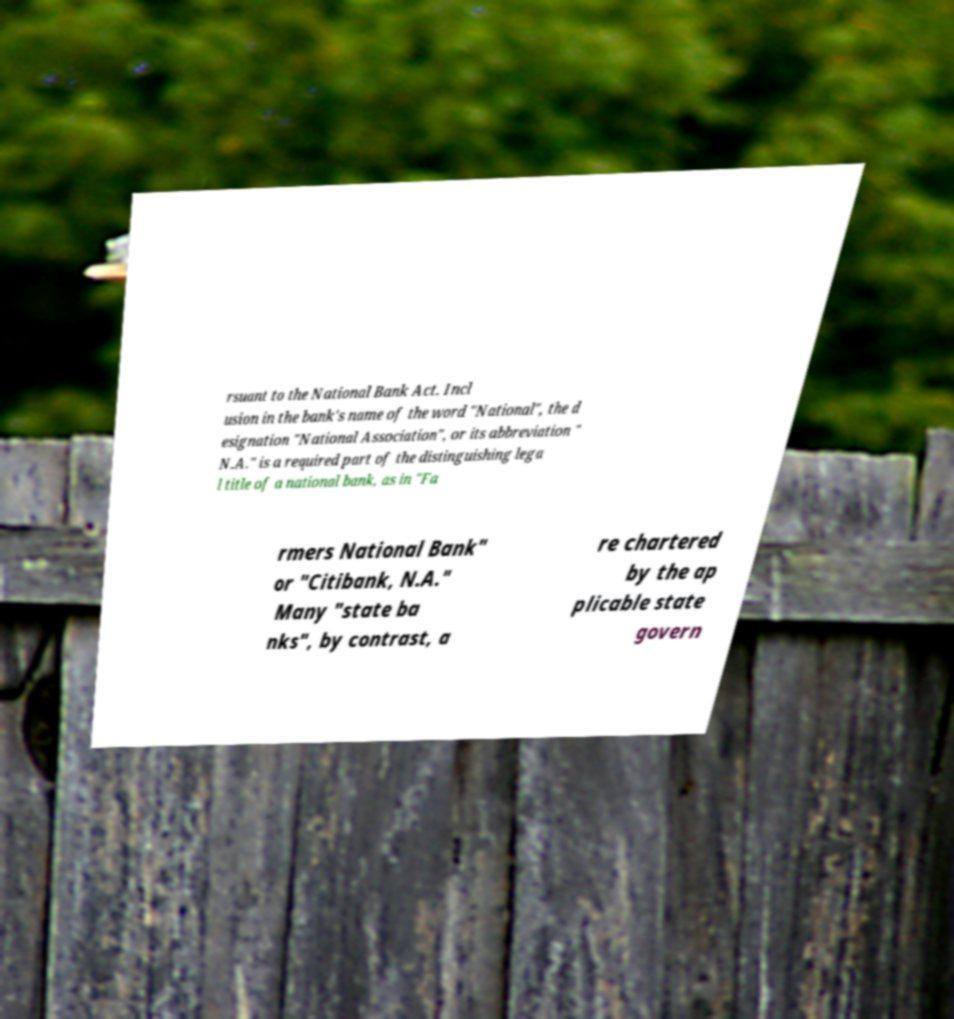Can you read and provide the text displayed in the image?This photo seems to have some interesting text. Can you extract and type it out for me? rsuant to the National Bank Act. Incl usion in the bank's name of the word "National", the d esignation "National Association", or its abbreviation " N.A." is a required part of the distinguishing lega l title of a national bank, as in "Fa rmers National Bank" or "Citibank, N.A." Many "state ba nks", by contrast, a re chartered by the ap plicable state govern 